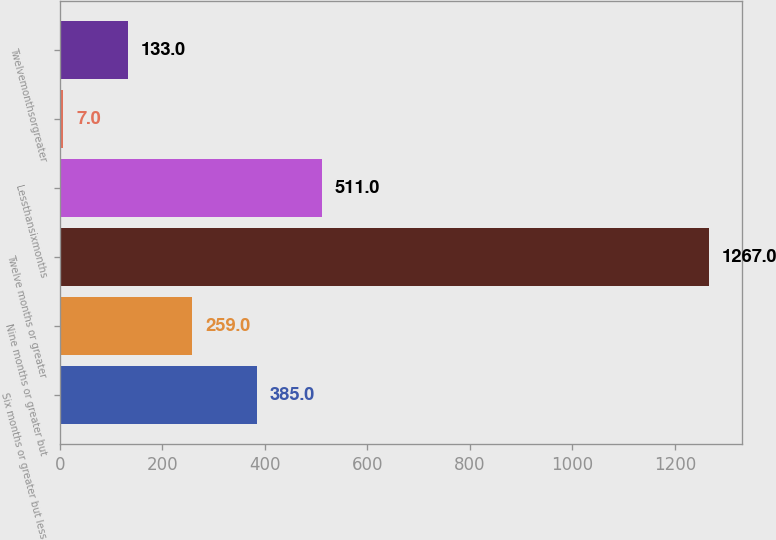<chart> <loc_0><loc_0><loc_500><loc_500><bar_chart><fcel>Six months or greater but less<fcel>Nine months or greater but<fcel>Twelve months or greater<fcel>Lessthansixmonths<fcel>Unnamed: 4<fcel>Twelvemonthsorgreater<nl><fcel>385<fcel>259<fcel>1267<fcel>511<fcel>7<fcel>133<nl></chart> 